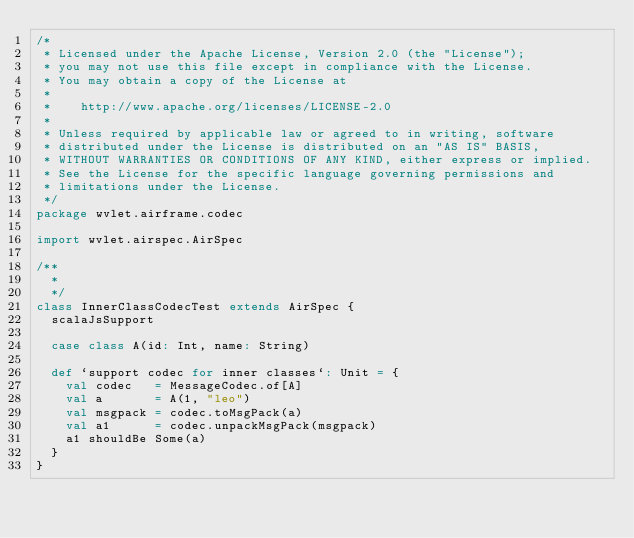Convert code to text. <code><loc_0><loc_0><loc_500><loc_500><_Scala_>/*
 * Licensed under the Apache License, Version 2.0 (the "License");
 * you may not use this file except in compliance with the License.
 * You may obtain a copy of the License at
 *
 *    http://www.apache.org/licenses/LICENSE-2.0
 *
 * Unless required by applicable law or agreed to in writing, software
 * distributed under the License is distributed on an "AS IS" BASIS,
 * WITHOUT WARRANTIES OR CONDITIONS OF ANY KIND, either express or implied.
 * See the License for the specific language governing permissions and
 * limitations under the License.
 */
package wvlet.airframe.codec

import wvlet.airspec.AirSpec

/**
  *
  */
class InnerClassCodecTest extends AirSpec {
  scalaJsSupport

  case class A(id: Int, name: String)

  def `support codec for inner classes`: Unit = {
    val codec   = MessageCodec.of[A]
    val a       = A(1, "leo")
    val msgpack = codec.toMsgPack(a)
    val a1      = codec.unpackMsgPack(msgpack)
    a1 shouldBe Some(a)
  }
}
</code> 